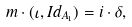<formula> <loc_0><loc_0><loc_500><loc_500>m \cdot ( \iota , I d _ { A _ { 1 } } ) = i \cdot { \delta } ,</formula> 